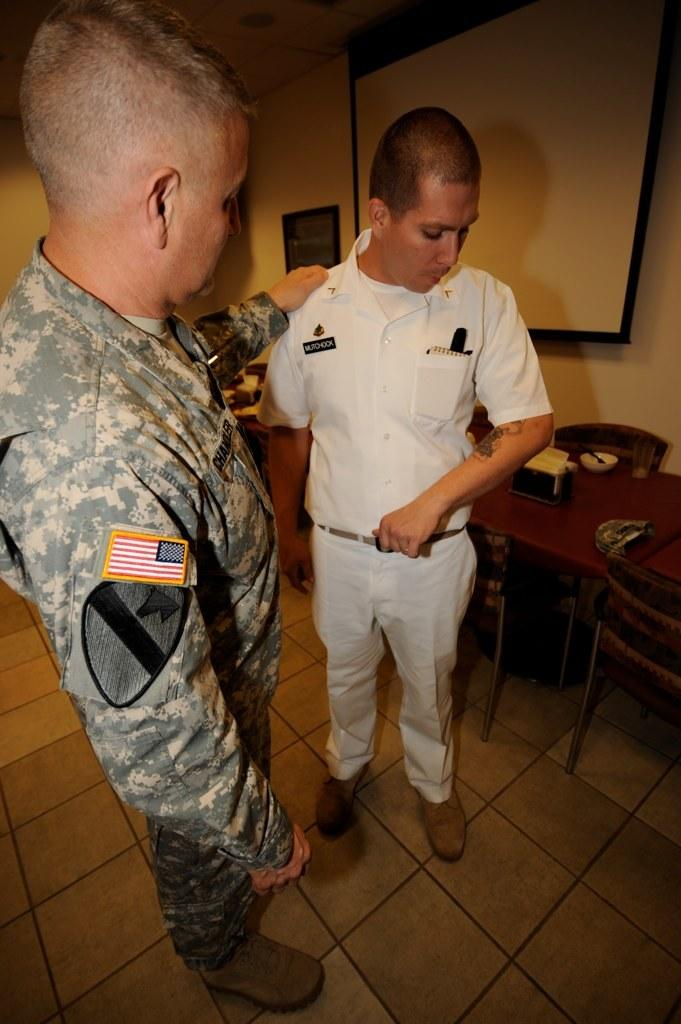How many people are present in the image? There are 2 people standing in the image. What type of uniform is the person on the right wearing? The person on the right is wearing a white uniform. What type of uniform is the person on the left wearing? The person on the left is wearing a military uniform. What type of furniture is present in the image? There is a table and chairs in the image. What type of cakes are being served by the governor in the image? There is no governor or cakes present in the image. 